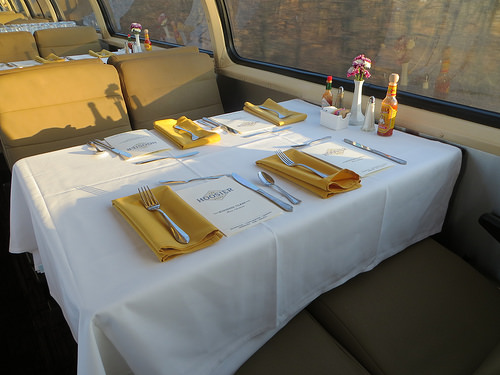<image>
Can you confirm if the window is to the left of the table? No. The window is not to the left of the table. From this viewpoint, they have a different horizontal relationship. 